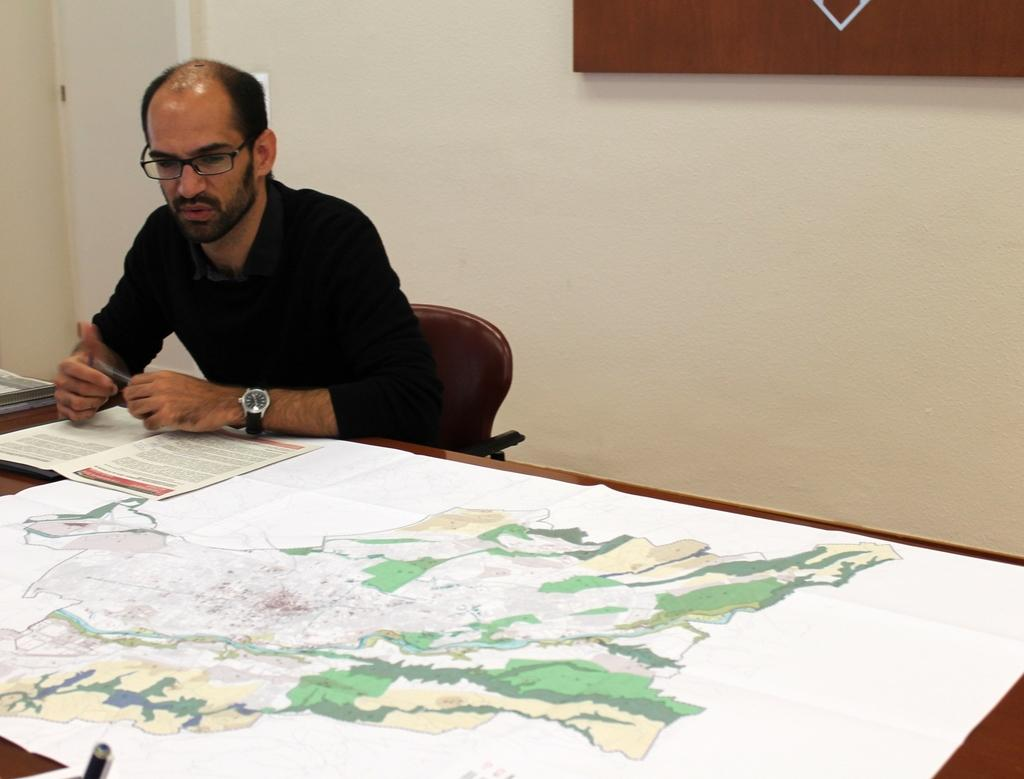Who is present in the image? There is a man in the image. What is the man doing in the image? The man is sitting on a chair. What is in front of the man? There is a table in front of the man. What is on the table? There is a paper and books on the table. What can be seen in the background of the image? There is a wall in the background of the image. What type of foot is visible in the image? There is no foot visible in the image; the man is sitting on a chair with his legs likely resting on the floor, but no foot is shown. 